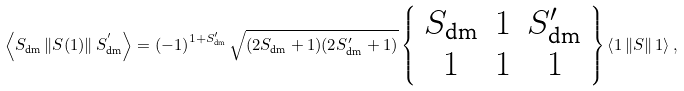Convert formula to latex. <formula><loc_0><loc_0><loc_500><loc_500>\left \langle S _ { \text {dm} } \left \| S ( 1 ) \right \| S _ { \text {dm} } ^ { ^ { \prime } } \right \rangle = \left ( - 1 \right ) ^ { 1 + S _ { \text {dm} } ^ { \prime } } \sqrt { ( 2 S _ { \text {dm} } + 1 ) ( 2 S _ { \text {dm} } ^ { \prime } + 1 ) } \left \{ \begin{array} { c c c } S _ { \text {dm} } & 1 & S _ { \text {dm} } ^ { \prime } \\ 1 & 1 & 1 \end{array} \right \} \left \langle 1 \left \| S \right \| 1 \right \rangle ,</formula> 